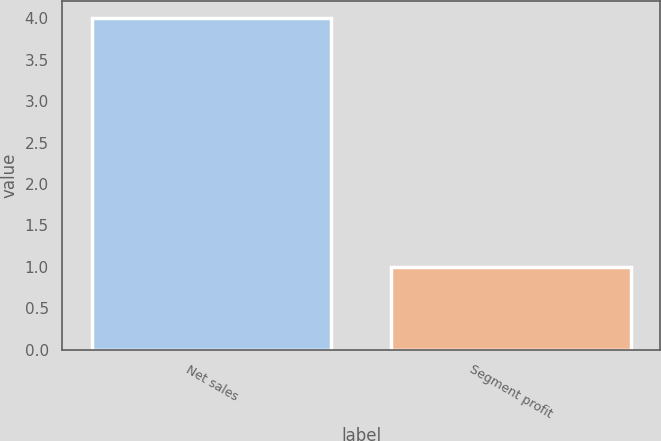Convert chart to OTSL. <chart><loc_0><loc_0><loc_500><loc_500><bar_chart><fcel>Net sales<fcel>Segment profit<nl><fcel>4<fcel>1<nl></chart> 